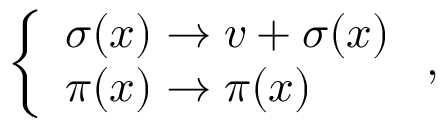Convert formula to latex. <formula><loc_0><loc_0><loc_500><loc_500>\left \{ \begin{array} { l l } { \sigma ( x ) \rightarrow v + \sigma ( x ) } \\ { \pi ( x ) \rightarrow \pi ( x ) } \end{array} ,</formula> 